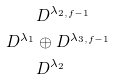Convert formula to latex. <formula><loc_0><loc_0><loc_500><loc_500>& D ^ { \lambda _ { 2 , f - 1 } } \\ D ^ { \lambda _ { 1 } } & \oplus D ^ { \lambda _ { 3 , f - 1 } } \\ & D ^ { \lambda _ { 2 } }</formula> 